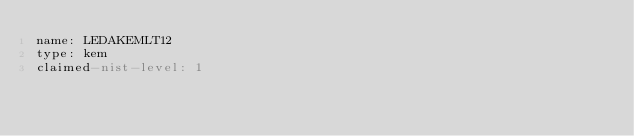<code> <loc_0><loc_0><loc_500><loc_500><_YAML_>name: LEDAKEMLT12
type: kem
claimed-nist-level: 1</code> 